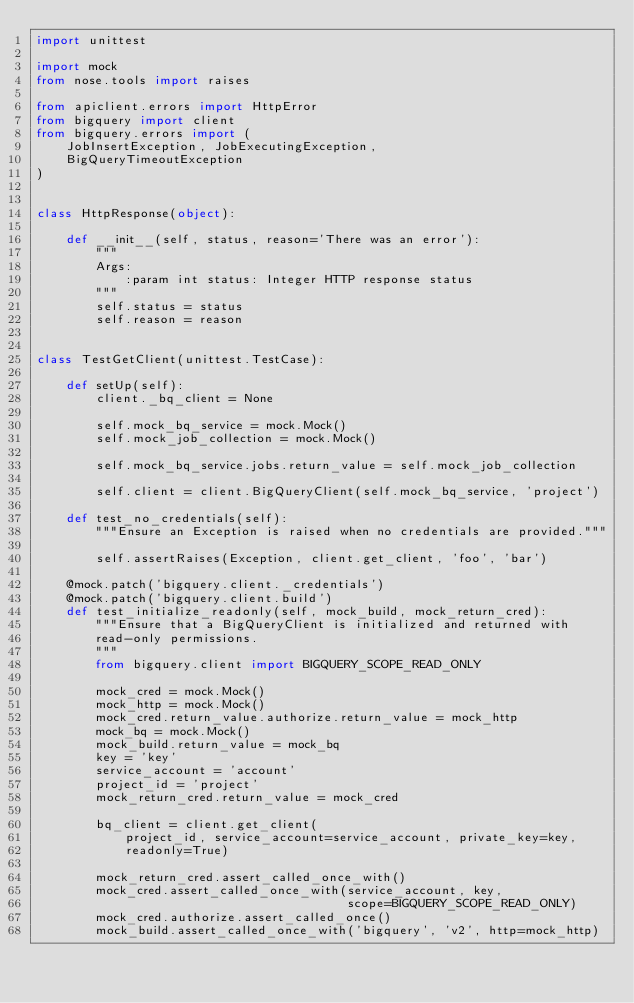<code> <loc_0><loc_0><loc_500><loc_500><_Python_>import unittest

import mock
from nose.tools import raises

from apiclient.errors import HttpError
from bigquery import client
from bigquery.errors import (
    JobInsertException, JobExecutingException,
    BigQueryTimeoutException
)


class HttpResponse(object):

    def __init__(self, status, reason='There was an error'):
        """
        Args:
            :param int status: Integer HTTP response status
        """
        self.status = status
        self.reason = reason


class TestGetClient(unittest.TestCase):

    def setUp(self):
        client._bq_client = None

        self.mock_bq_service = mock.Mock()
        self.mock_job_collection = mock.Mock()

        self.mock_bq_service.jobs.return_value = self.mock_job_collection

        self.client = client.BigQueryClient(self.mock_bq_service, 'project')

    def test_no_credentials(self):
        """Ensure an Exception is raised when no credentials are provided."""

        self.assertRaises(Exception, client.get_client, 'foo', 'bar')

    @mock.patch('bigquery.client._credentials')
    @mock.patch('bigquery.client.build')
    def test_initialize_readonly(self, mock_build, mock_return_cred):
        """Ensure that a BigQueryClient is initialized and returned with
        read-only permissions.
        """
        from bigquery.client import BIGQUERY_SCOPE_READ_ONLY

        mock_cred = mock.Mock()
        mock_http = mock.Mock()
        mock_cred.return_value.authorize.return_value = mock_http
        mock_bq = mock.Mock()
        mock_build.return_value = mock_bq
        key = 'key'
        service_account = 'account'
        project_id = 'project'
        mock_return_cred.return_value = mock_cred

        bq_client = client.get_client(
            project_id, service_account=service_account, private_key=key,
            readonly=True)

        mock_return_cred.assert_called_once_with()
        mock_cred.assert_called_once_with(service_account, key,
                                          scope=BIGQUERY_SCOPE_READ_ONLY)
        mock_cred.authorize.assert_called_once()
        mock_build.assert_called_once_with('bigquery', 'v2', http=mock_http)</code> 